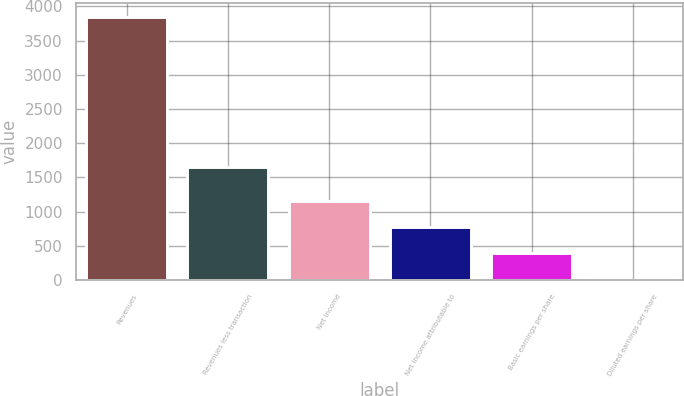Convert chart to OTSL. <chart><loc_0><loc_0><loc_500><loc_500><bar_chart><fcel>Revenues<fcel>Revenues less transaction<fcel>Net income<fcel>Net income attributable to<fcel>Basic earnings per share<fcel>Diluted earnings per share<nl><fcel>3853<fcel>1652<fcel>1156.92<fcel>771.77<fcel>386.61<fcel>1.45<nl></chart> 